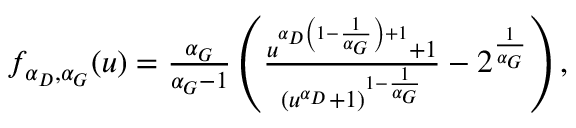Convert formula to latex. <formula><loc_0><loc_0><loc_500><loc_500>\begin{array} { r } { f _ { \alpha _ { D } , \alpha _ { G } } ( u ) = \frac { \alpha _ { G } } { \alpha _ { G } - 1 } \left ( \frac { u ^ { \alpha _ { D } \left ( 1 - \frac { 1 } { \alpha _ { G } } \right ) + 1 } + 1 } { ( u ^ { \alpha _ { D } } + 1 ) ^ { 1 - \frac { 1 } { \alpha _ { G } } } } - 2 ^ { \frac { 1 } { \alpha _ { G } } } \right ) , } \end{array}</formula> 